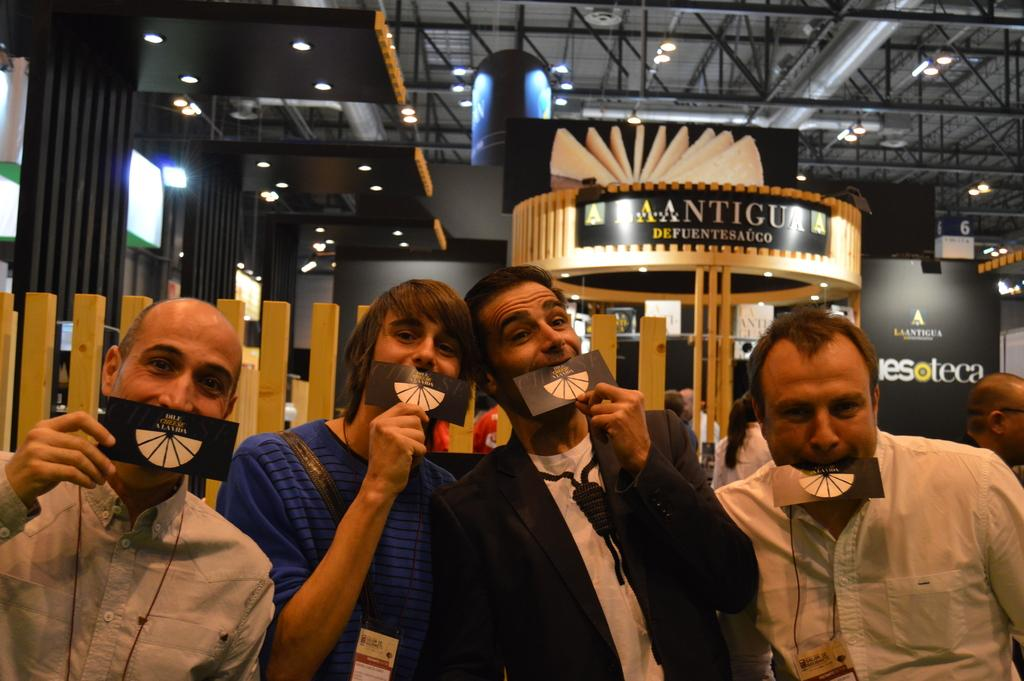How many people are present in the image? There are four persons in the image. What are the persons holding in the image? The persons are holding a card in the image. Can you describe the color scheme of the card? The card is in white and black color. What can be seen in the background of the image? There is a wooden railing and lights visible in the background of the image. What type of bead is used to create the pattern on the card? There is no bead used to create a pattern on the card; it is in white and black color. How many tickets are visible in the image? There are no tickets visible in the image; it features four persons holding a card. 